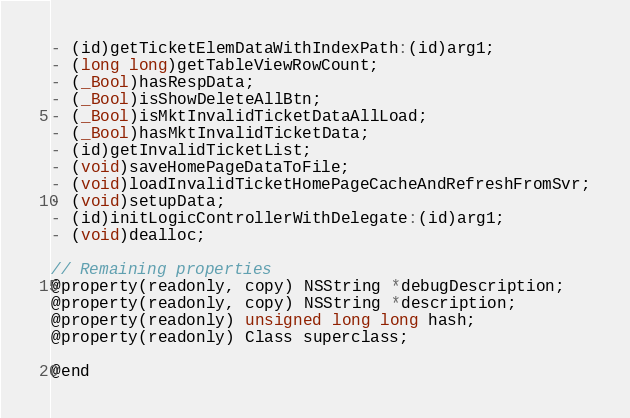Convert code to text. <code><loc_0><loc_0><loc_500><loc_500><_C_>- (id)getTicketElemDataWithIndexPath:(id)arg1;
- (long long)getTableViewRowCount;
- (_Bool)hasRespData;
- (_Bool)isShowDeleteAllBtn;
- (_Bool)isMktInvalidTicketDataAllLoad;
- (_Bool)hasMktInvalidTicketData;
- (id)getInvalidTicketList;
- (void)saveHomePageDataToFile;
- (void)loadInvalidTicketHomePageCacheAndRefreshFromSvr;
- (void)setupData;
- (id)initLogicControllerWithDelegate:(id)arg1;
- (void)dealloc;

// Remaining properties
@property(readonly, copy) NSString *debugDescription;
@property(readonly, copy) NSString *description;
@property(readonly) unsigned long long hash;
@property(readonly) Class superclass;

@end

</code> 